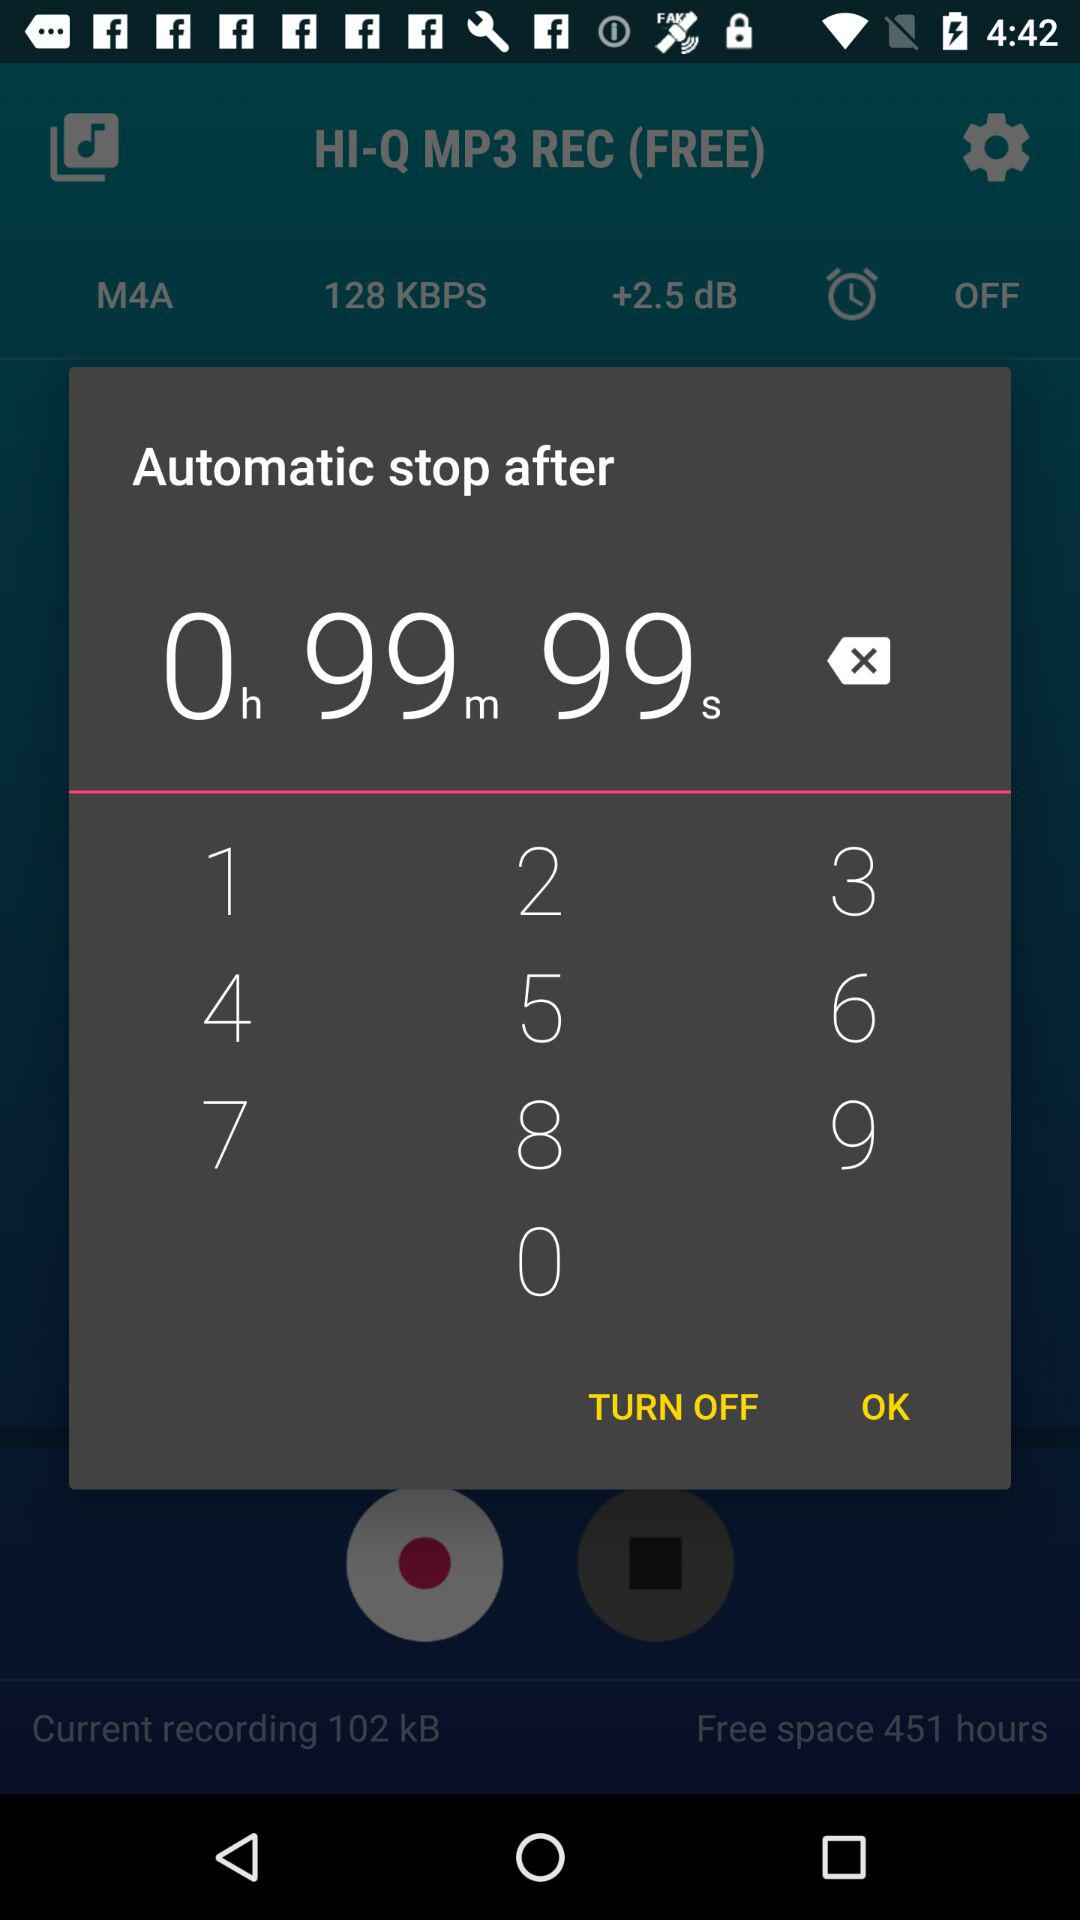How many hours are there in "Free space"? There are 451 hours in "Free space". 